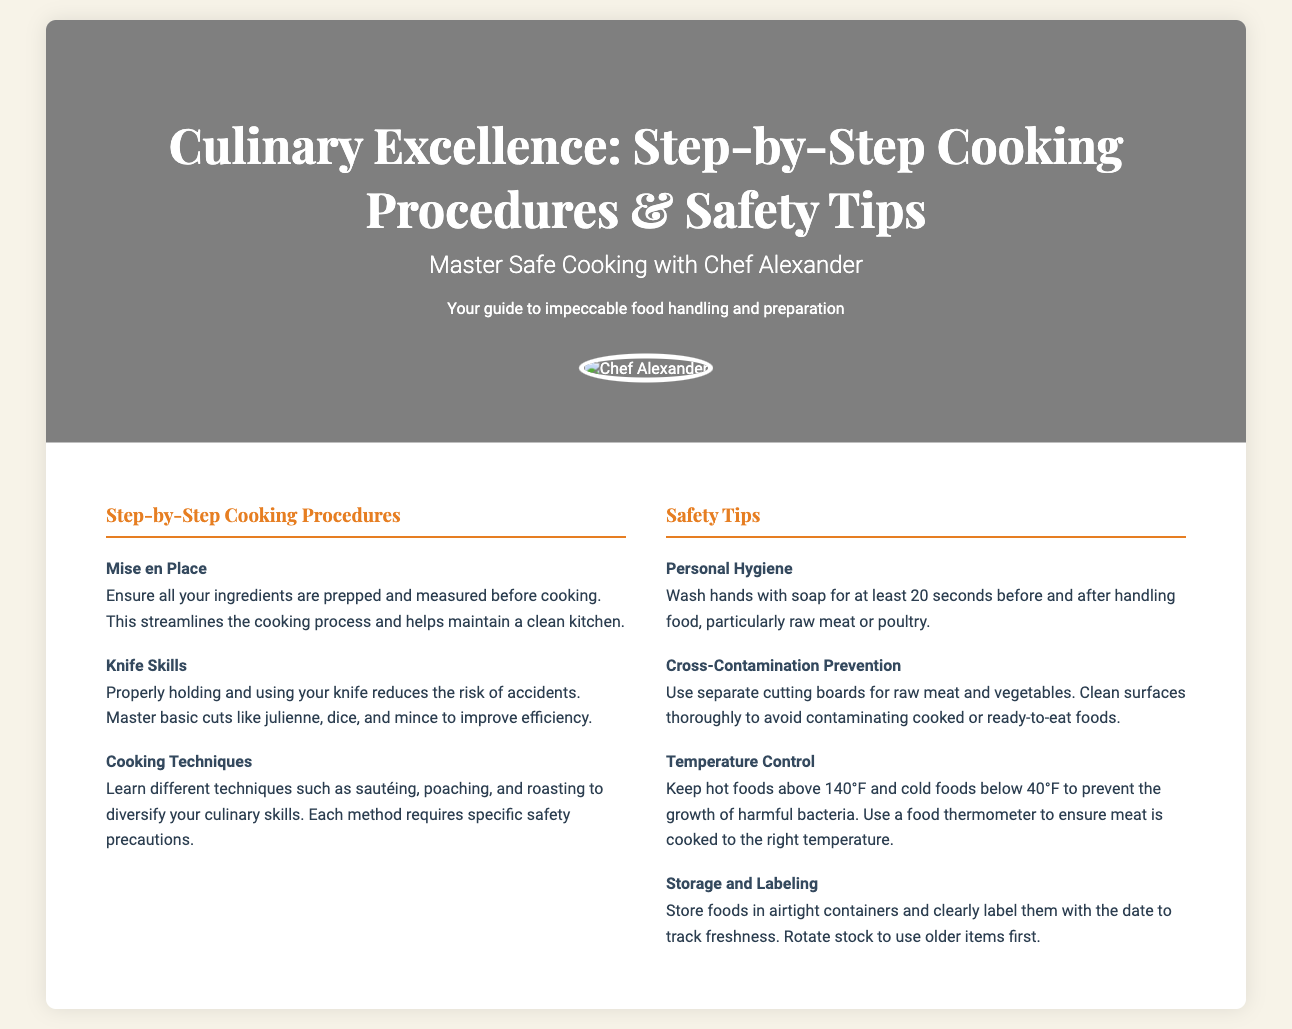What is the title of the document? The title of the document is prominently displayed on the front cover of the product packaging.
Answer: Culinary Excellence: Step-by-Step Cooking Procedures & Safety Tips Who is the instructor mentioned in the document? The document features the name of the culinary instructor in the subtitle.
Answer: Chef Alexander What is the first cooking procedure listed? The first cooking procedure is highlighted under the section for Step-by-Step Cooking Procedures.
Answer: Mise en Place What temperature should hot foods be kept above? The document states specific temperature guidelines for food safety, mentioning the required temperature for hot foods.
Answer: 140°F What is one of the safety tips related to personal hygiene? The document provides advice on hygiene practices related to food handling.
Answer: Wash hands with soap for at least 20 seconds What should be used to prevent cross-contamination? The document offers guidelines to avoid cross-contamination while preparing food.
Answer: Separate cutting boards Which cooking technique is mentioned in the document? The cooking techniques are listed in the section on cooking procedures.
Answer: Sautéing What should food containers be? The document advises on how to store foods correctly for safety.
Answer: Airtight What is emphasized as essential to track the freshness of stored foods? The document mentions a practice related to labeling to keep track of food freshness.
Answer: Clearly label them with the date What does the chef image look like? The document describes the appearance and style of the chef's image presented on the front cover.
Answer: Circular, with a border 